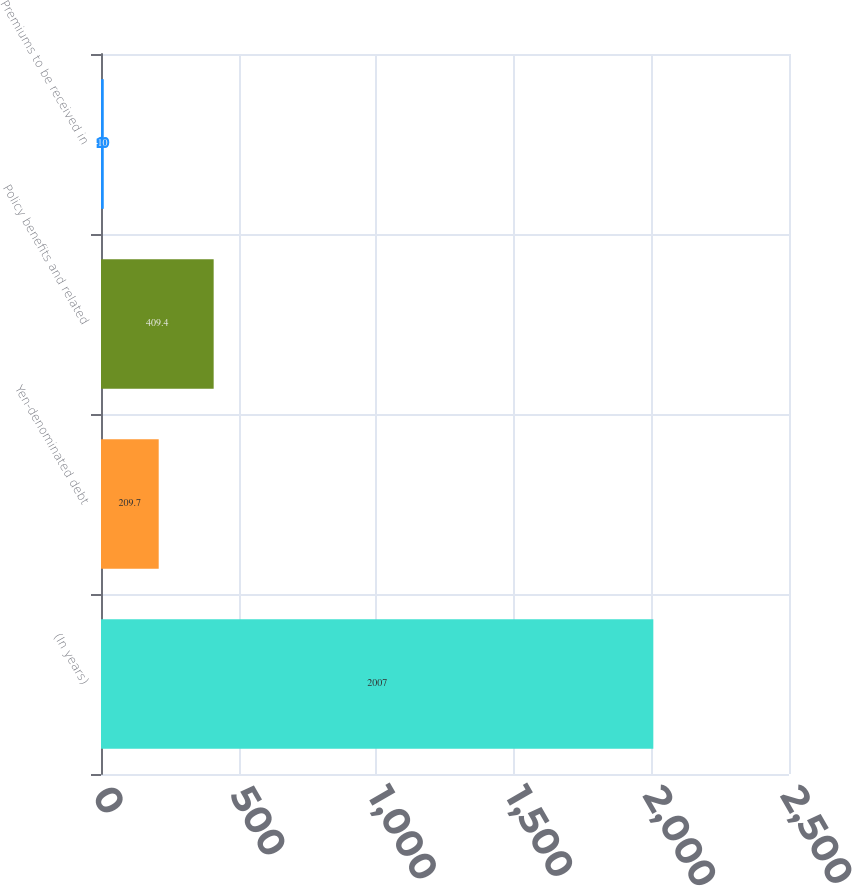Convert chart. <chart><loc_0><loc_0><loc_500><loc_500><bar_chart><fcel>(In years)<fcel>Yen-denominated debt<fcel>Policy benefits and related<fcel>Premiums to be received in<nl><fcel>2007<fcel>209.7<fcel>409.4<fcel>10<nl></chart> 